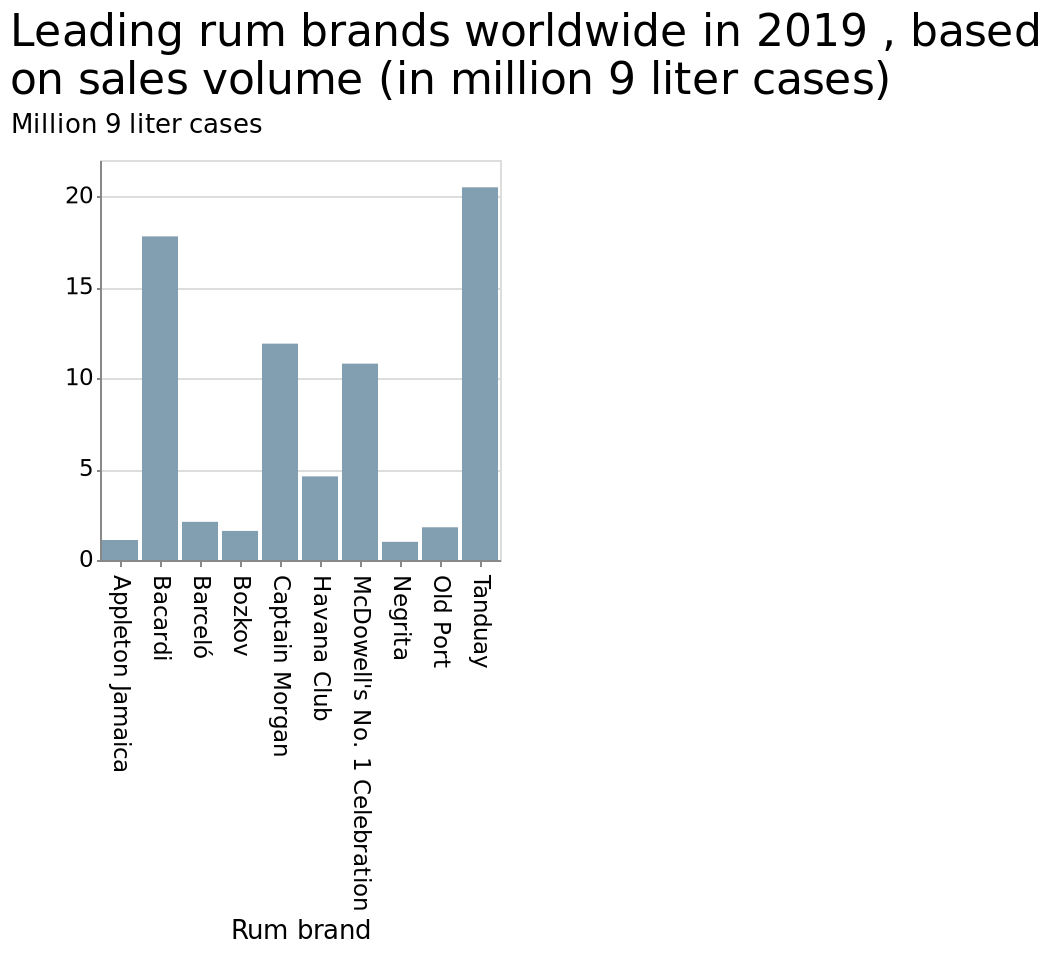<image>
please summary the statistics and relations of the chart The rum brand that has sold the most in 2019 is Tanduay, having sold more than 20 million 9 liter cases. The rum brand that has sold the second most in 2019 is Barcadi. What is the range of values on the y-axis? The y-axis ranges from a minimum of 0 to a maximum of 20. What does the bar plot represent? The bar plot represents the leading rum brands worldwide in 2019 based on sales volume in million 9 liter cases. Has the rum brand Barcadi sold more than 20 million 9 liter cases in 2019? No.The rum brand that has sold the most in 2019 is Tanduay, having sold more than 20 million 9 liter cases. The rum brand that has sold the second most in 2019 is Barcadi. 